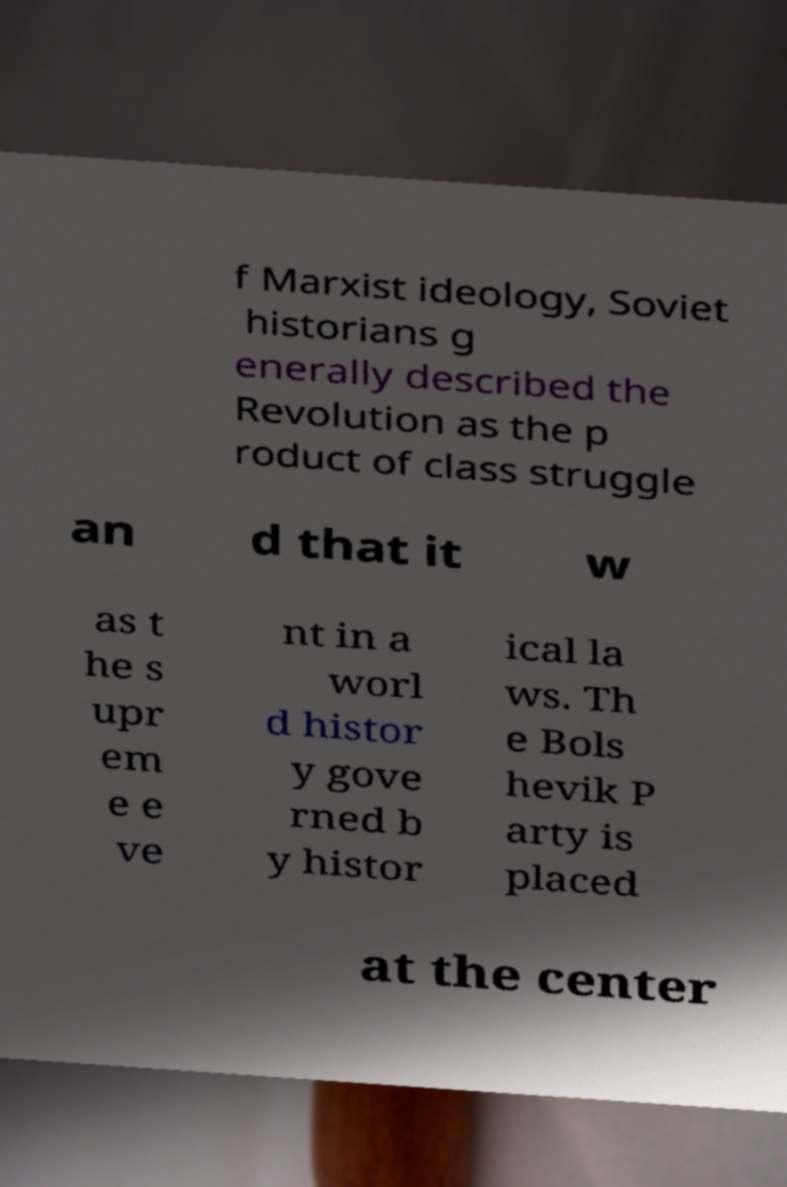Can you read and provide the text displayed in the image?This photo seems to have some interesting text. Can you extract and type it out for me? f Marxist ideology, Soviet historians g enerally described the Revolution as the p roduct of class struggle an d that it w as t he s upr em e e ve nt in a worl d histor y gove rned b y histor ical la ws. Th e Bols hevik P arty is placed at the center 